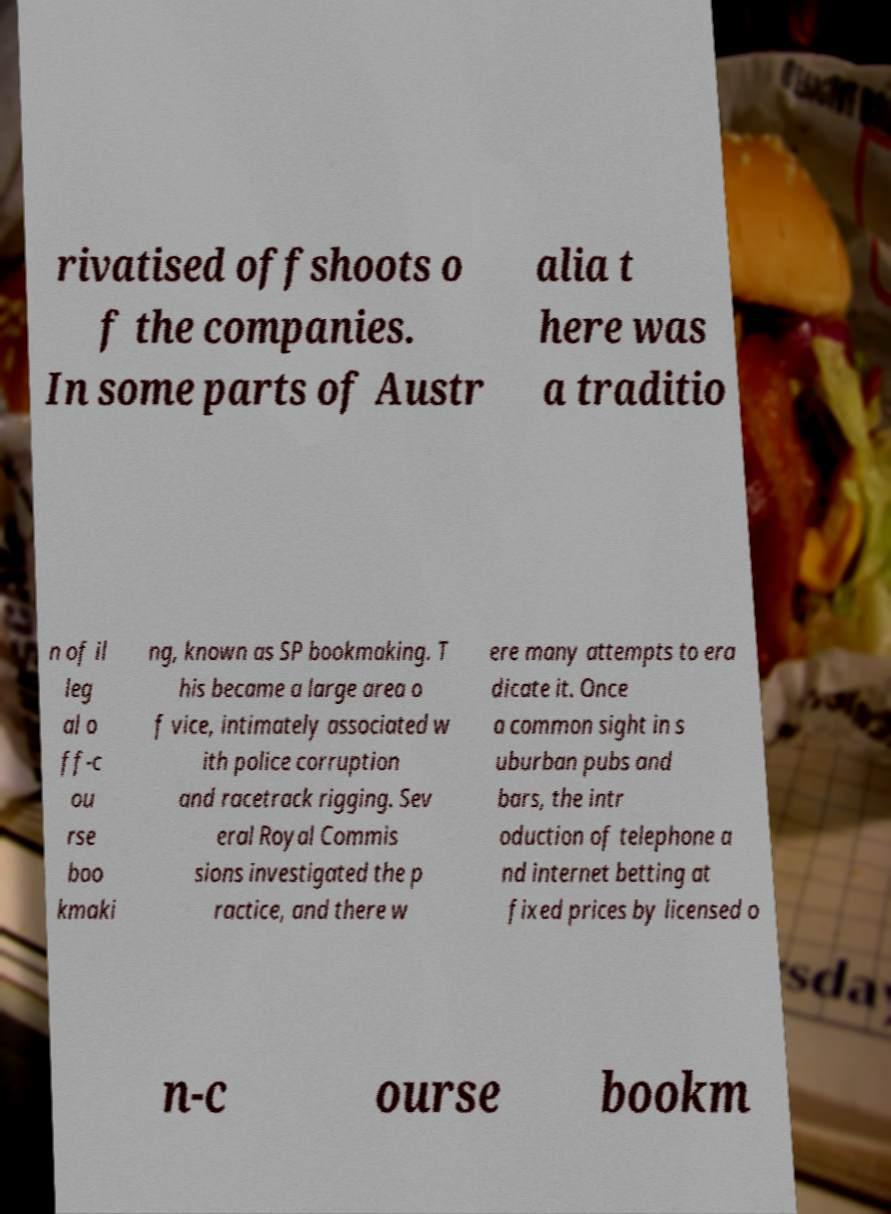There's text embedded in this image that I need extracted. Can you transcribe it verbatim? rivatised offshoots o f the companies. In some parts of Austr alia t here was a traditio n of il leg al o ff-c ou rse boo kmaki ng, known as SP bookmaking. T his became a large area o f vice, intimately associated w ith police corruption and racetrack rigging. Sev eral Royal Commis sions investigated the p ractice, and there w ere many attempts to era dicate it. Once a common sight in s uburban pubs and bars, the intr oduction of telephone a nd internet betting at fixed prices by licensed o n-c ourse bookm 